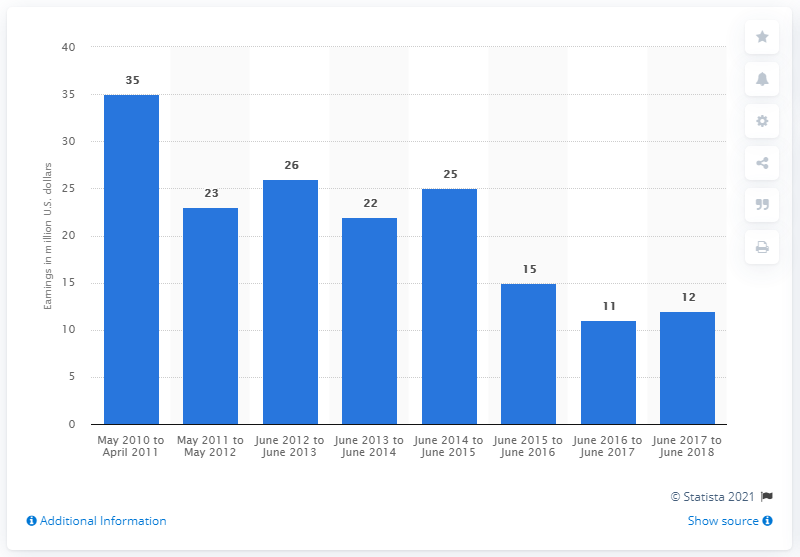Mention a couple of crucial points in this snapshot. Danielle Steel earned a significant amount of money between June 2017 and June 2018, which is evident from her financial records. I am not at liberty to disclose the earnings of Danielle Steel from a year earlier. 